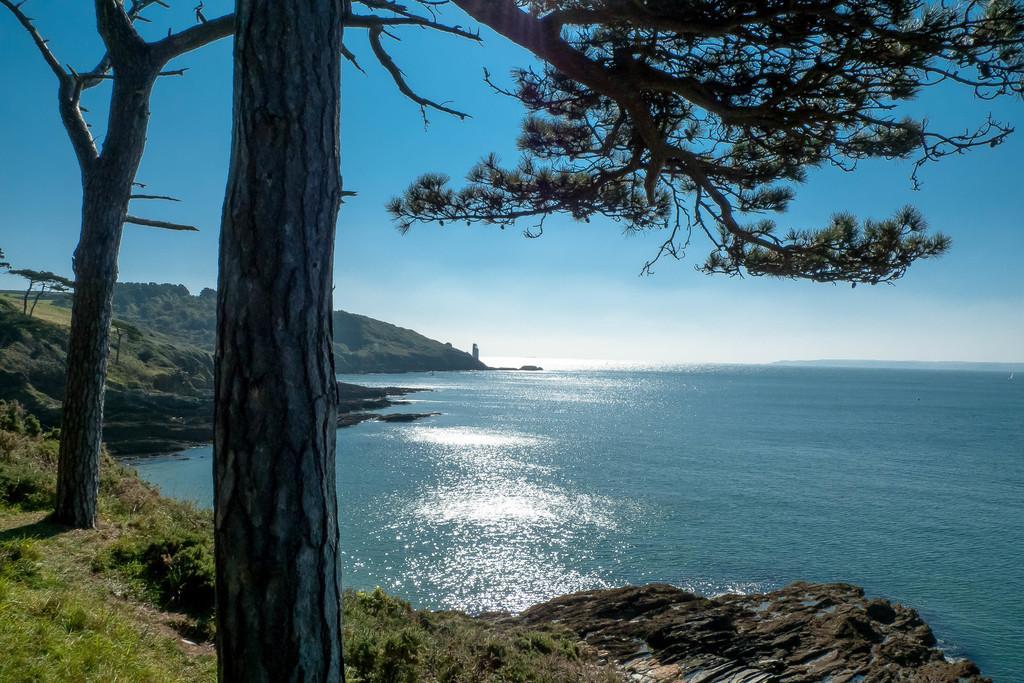Describe this image in one or two sentences. Here we can see trees, grass and water. Sky is in blue color. 